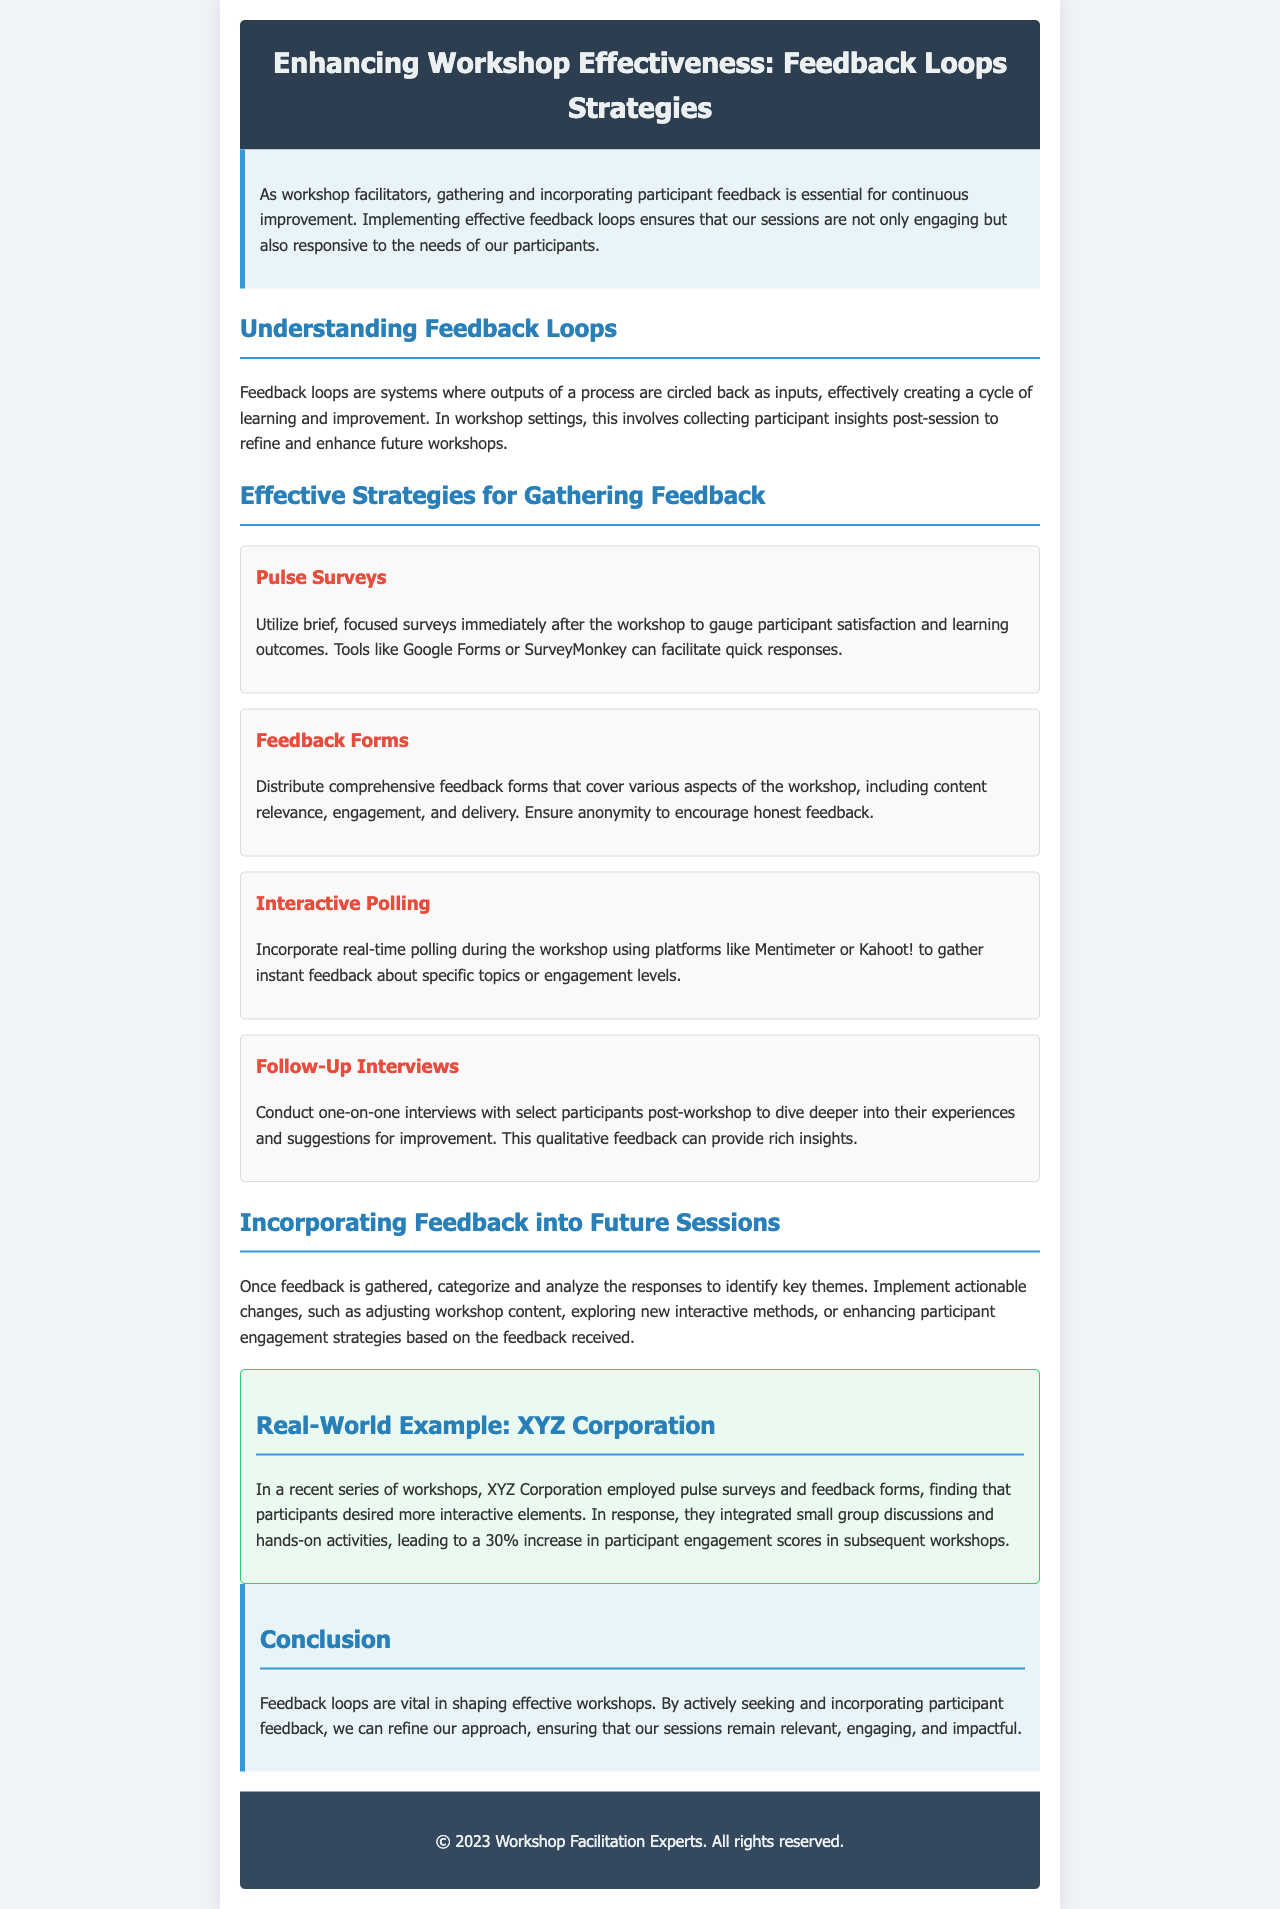What are feedback loops? Feedback loops are systems where outputs of a process are circled back as inputs, creating a cycle of learning and improvement.
Answer: Systems What is the title of the newsletter? The title of the newsletter is presented at the top of the document.
Answer: Enhancing Workshop Effectiveness: Feedback Loops Strategies How many strategies for gathering feedback are mentioned? The document lists several strategies for gathering feedback, and it's essential to count them.
Answer: Four What is the real-world example organization mentioned? The document provides a specific example of an organization that applied feedback strategies.
Answer: XYZ Corporation What tool can be used for pulse surveys? The document suggests specific tools that can be used to facilitate pulse surveys.
Answer: Google Forms Why is anonymity important in feedback forms? The document implies a reason for ensuring anonymity in feedback forms to encourage a certain behavior.
Answer: Encourages honest feedback How did XYZ Corporation increase participant engagement scores? The document explains how a specific change led to a measurable outcome regarding engagement.
Answer: Integrated small group discussions and hands-on activities What colors are used in the header of the newsletter? By observing the style provided in the document, the colors used in the header can be determined.
Answer: Dark blue and white What is the purpose of follow-up interviews? The document describes the goal behind conducting follow-up interviews with participants.
Answer: Dive deeper into experiences and suggestions 